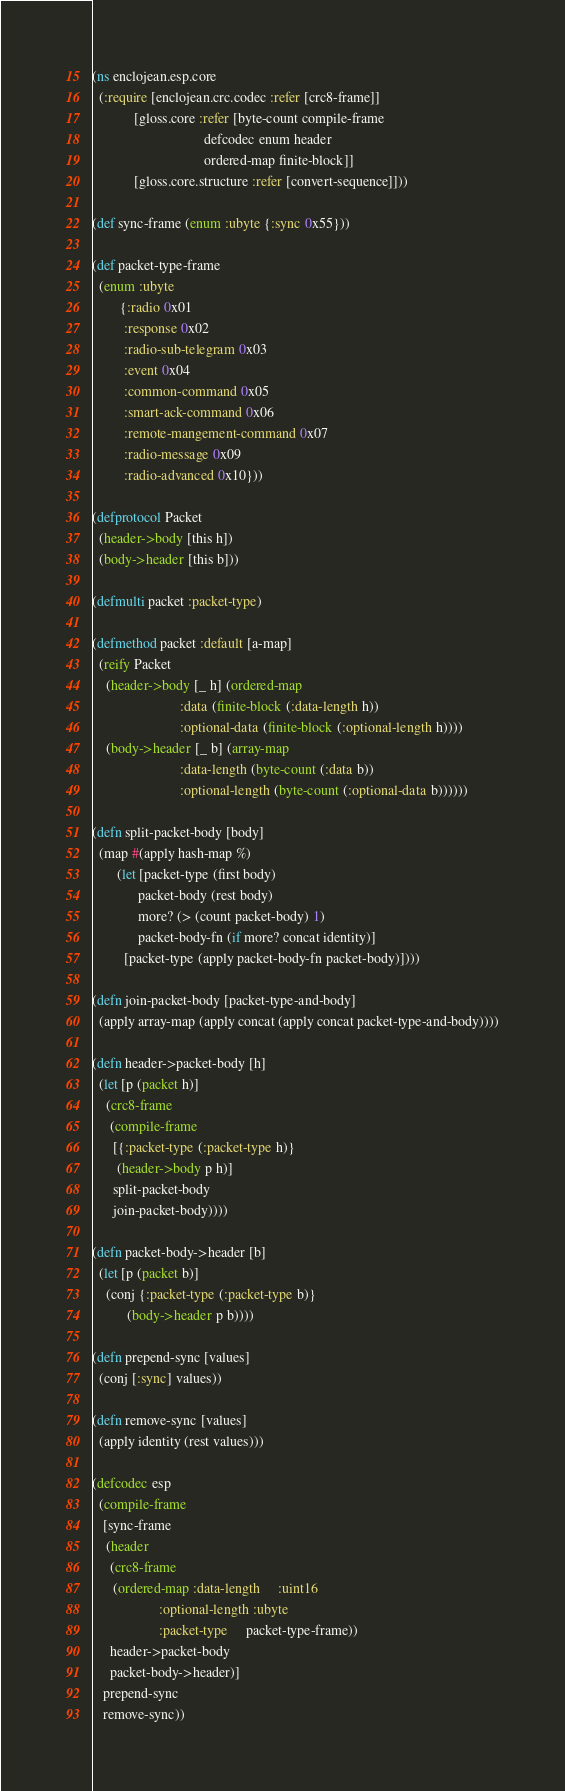<code> <loc_0><loc_0><loc_500><loc_500><_Clojure_>(ns enclojean.esp.core
  (:require [enclojean.crc.codec :refer [crc8-frame]]
            [gloss.core :refer [byte-count compile-frame
                                defcodec enum header
                                ordered-map finite-block]]
            [gloss.core.structure :refer [convert-sequence]]))

(def sync-frame (enum :ubyte {:sync 0x55}))

(def packet-type-frame
  (enum :ubyte
        {:radio 0x01
         :response 0x02
         :radio-sub-telegram 0x03
         :event 0x04
         :common-command 0x05
         :smart-ack-command 0x06
         :remote-mangement-command 0x07
         :radio-message 0x09
         :radio-advanced 0x10}))

(defprotocol Packet
  (header->body [this h])
  (body->header [this b]))

(defmulti packet :packet-type)

(defmethod packet :default [a-map]
  (reify Packet
    (header->body [_ h] (ordered-map
                         :data (finite-block (:data-length h))
                         :optional-data (finite-block (:optional-length h))))
    (body->header [_ b] (array-map
                         :data-length (byte-count (:data b))
                         :optional-length (byte-count (:optional-data b))))))

(defn split-packet-body [body]
  (map #(apply hash-map %)
       (let [packet-type (first body)
             packet-body (rest body)
             more? (> (count packet-body) 1)
             packet-body-fn (if more? concat identity)]
         [packet-type (apply packet-body-fn packet-body)])))

(defn join-packet-body [packet-type-and-body]
  (apply array-map (apply concat (apply concat packet-type-and-body))))

(defn header->packet-body [h]
  (let [p (packet h)]
    (crc8-frame
     (compile-frame
      [{:packet-type (:packet-type h)}
       (header->body p h)]
      split-packet-body
      join-packet-body))))

(defn packet-body->header [b]
  (let [p (packet b)]
    (conj {:packet-type (:packet-type b)}
          (body->header p b))))

(defn prepend-sync [values]
  (conj [:sync] values))

(defn remove-sync [values]
  (apply identity (rest values)))

(defcodec esp
  (compile-frame
   [sync-frame
    (header
     (crc8-frame
      (ordered-map :data-length     :uint16
                   :optional-length :ubyte
                   :packet-type     packet-type-frame))
     header->packet-body
     packet-body->header)]
   prepend-sync
   remove-sync))
</code> 